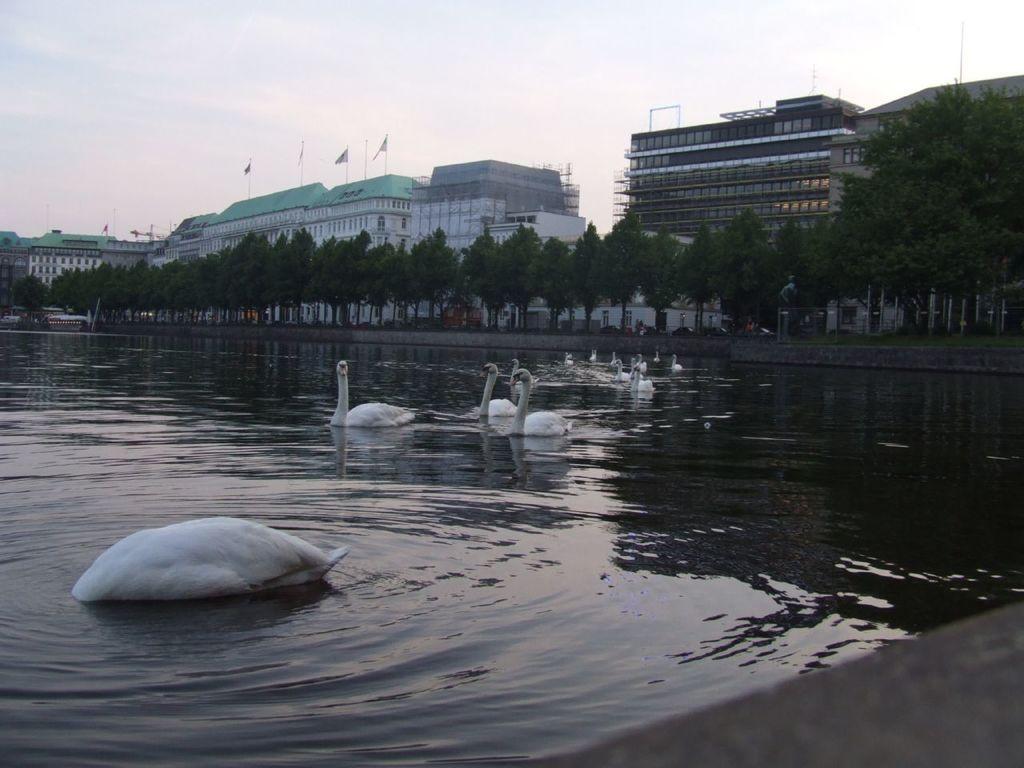Please provide a concise description of this image. In this image we can see a group of swans in the water body. On the backside we can see a group of buildings, trees, poles and the sky which looks cloudy. 